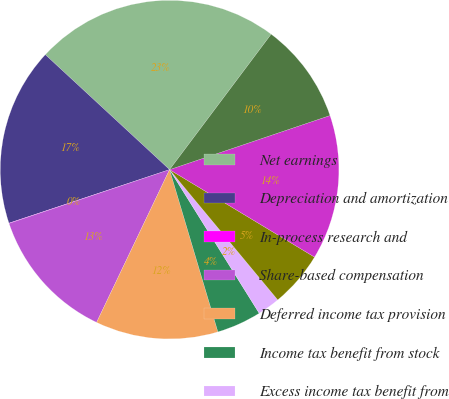Convert chart. <chart><loc_0><loc_0><loc_500><loc_500><pie_chart><fcel>Net earnings<fcel>Depreciation and amortization<fcel>In-process research and<fcel>Share-based compensation<fcel>Deferred income tax provision<fcel>Income tax benefit from stock<fcel>Excess income tax benefit from<fcel>Income taxes payable<fcel>Receivables<fcel>Inventories<nl><fcel>23.36%<fcel>17.0%<fcel>0.03%<fcel>12.76%<fcel>11.7%<fcel>4.27%<fcel>2.15%<fcel>5.33%<fcel>13.82%<fcel>9.58%<nl></chart> 